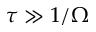Convert formula to latex. <formula><loc_0><loc_0><loc_500><loc_500>\tau \gg 1 / \Omega</formula> 